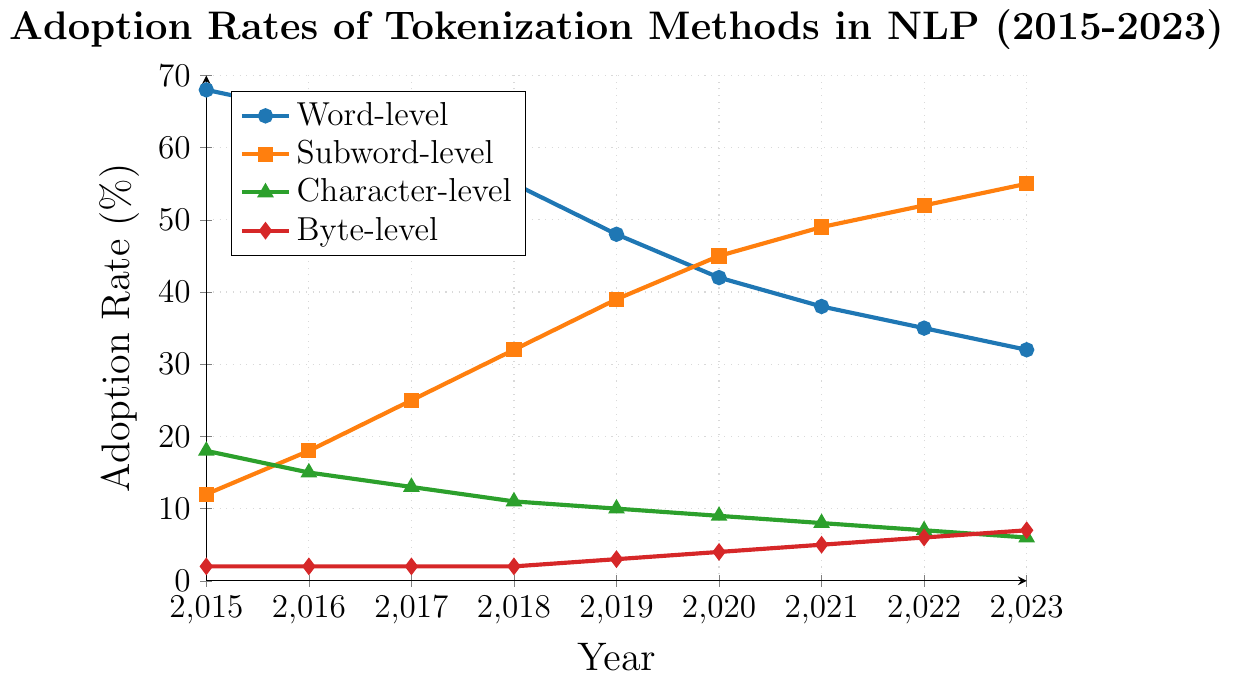What is the adoption rate of subword-level tokenization in 2020? Look at the subword-level tokenization line, which is represented by the orange line with square markers. Find the point for the year 2020 and check the adoption rate on the y-axis.
Answer: 45% How has the adoption rate of word-level tokenization changed from 2015 to 2023? Look at the word-level tokenization line, which is represented by the blue line with circular markers. Compare the adoption rate in 2015 (68%) and in 2023 (32%).
Answer: Decreased by 36% Which tokenization method had the highest adoption rate in 2019, and what was it? Compare the adoption rates of all tokenization methods in 2019 by checking their respective lines.
Answer: Word-level at 48% Between 2015 and 2023, which tokenization method showed the most consistent increase in adoption rate? Look for the line with a steadily increasing adoption rate from 2015 to 2023. The orange line representing subword-level tokenization shows a consistent increase.
Answer: Subword-level What is the difference in adoption rates between subword-level and character-level tokenization in 2023? Check the adoption rates for subword-level (55%) and character-level (6%) in 2023 and calculate the difference.
Answer: 49% Which tokenization method had the lowest adoption rate in 2015? Compare the adoption rates of all tokenization methods in 2015. Byte-level has the lowest rate of 2%.
Answer: Byte-level By how much did the adoption rate of byte-level tokenization increase from 2015 to 2023? Check the adoption rates for byte-level tokenization in 2015 (2%) and 2023 (7%) and calculate the difference.
Answer: Increased by 5% How many tokenization methods had an adoption rate greater than 10% in 2018? Look at the y-values for each tokenization method in 2018 and count how many are greater than 10%. Word-level (55%), subword-level (32%), and character-level (11%) are above 10%.
Answer: 3 Rank the tokenization methods by their adoption rate in 2023 from highest to lowest. Compare the adoption rates in 2023: subword-level (55%), word-level (32%), byte-level (7%), and character-level (6%).
Answer: Subword-level, Word-level, Byte-level, Character-level What was the average adoption rate of subword-level tokenization between 2015 and 2023? Sum the adoption rates of subword-level tokenization for all years and divide by the number of years: (12+18+25+32+39+45+49+52+55)/9.
Answer: 36.33 